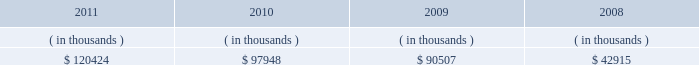System energy resources , inc .
Management 2019s financial discussion and analysis sources of capital system energy 2019s sources to meet its capital requirements include : internally generated funds ; cash on hand ; debt issuances ; and bank financing under new or existing facilities .
System energy may refinance , redeem , or otherwise retire debt prior to maturity , to the extent market conditions and interest and dividend rates are favorable .
All debt and common stock issuances by system energy require prior regulatory approval .
Debt issuances are also subject to issuance tests set forth in its bond indentures and other agreements .
System energy has sufficient capacity under these tests to meet its foreseeable capital needs .
In february 2012 , system energy vie issued $ 50 million of 4.02% ( 4.02 % ) series h notes due february 2017 .
System energy used the proceeds to purchase additional nuclear fuel .
System energy has obtained a short-term borrowing authorization from the ferc under which it may borrow , through october 2013 , up to the aggregate amount , at any one time outstanding , of $ 200 million .
See note 4 to the financial statements for further discussion of system energy 2019s short-term borrowing limits .
System energy has also obtained an order from the ferc authorizing long-term securities issuances .
The current long-term authorization extends through july 2013 .
System energy 2019s receivables from the money pool were as follows as of december 31 for each of the following years: .
See note 4 to the financial statements for a description of the money pool .
Nuclear matters system energy owns and operates grand gulf .
System energy is , therefore , subject to the risks related to owning and operating a nuclear plant .
These include risks from the use , storage , handling and disposal of high- level and low-level radioactive materials , regulatory requirement changes , including changes resulting from events at other plants , limitations on the amounts and types of insurance commercially available for losses in connection with nuclear operations , and technological and financial uncertainties related to decommissioning nuclear plants at the end of their licensed lives , including the sufficiency of funds in decommissioning trusts .
In the event of an unanticipated early shutdown of grand gulf , system energy may be required to provide additional funds or credit support to satisfy regulatory requirements for decommissioning .
After the nuclear incident in japan resulting from the march 2011 earthquake and tsunami , the nrc established a task force to conduct a review of processes and regulations relating to nuclear facilities in the united states .
The task force issued a near term ( 90-day ) report in july 2011 that has made recommendations , which are currently being evaluated by the nrc .
It is anticipated that the nrc will issue certain orders and requests for information to nuclear plant licensees by the end of the first quarter 2012 that will begin to implement the task force 2019s recommendations .
These orders may require u.s .
Nuclear operators , including entergy , to undertake plant modifications or perform additional analyses that could , among other things , result in increased costs and capital requirements associated with operating entergy 2019s nuclear plants. .
What will be the yearly interest expense for system energy vie for the note issued in 2012 , ( in millions ) ? 
Computations: (50 - 4.02%)
Answer: 49.9598. 